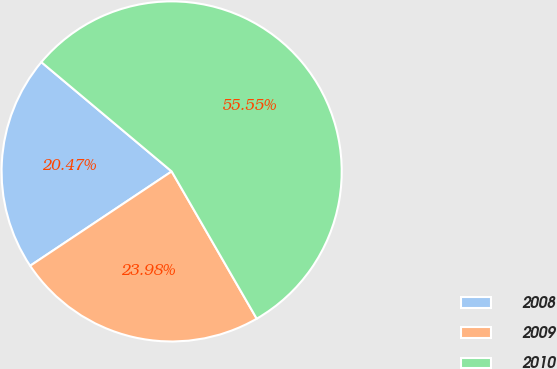Convert chart. <chart><loc_0><loc_0><loc_500><loc_500><pie_chart><fcel>2008<fcel>2009<fcel>2010<nl><fcel>20.47%<fcel>23.98%<fcel>55.56%<nl></chart> 